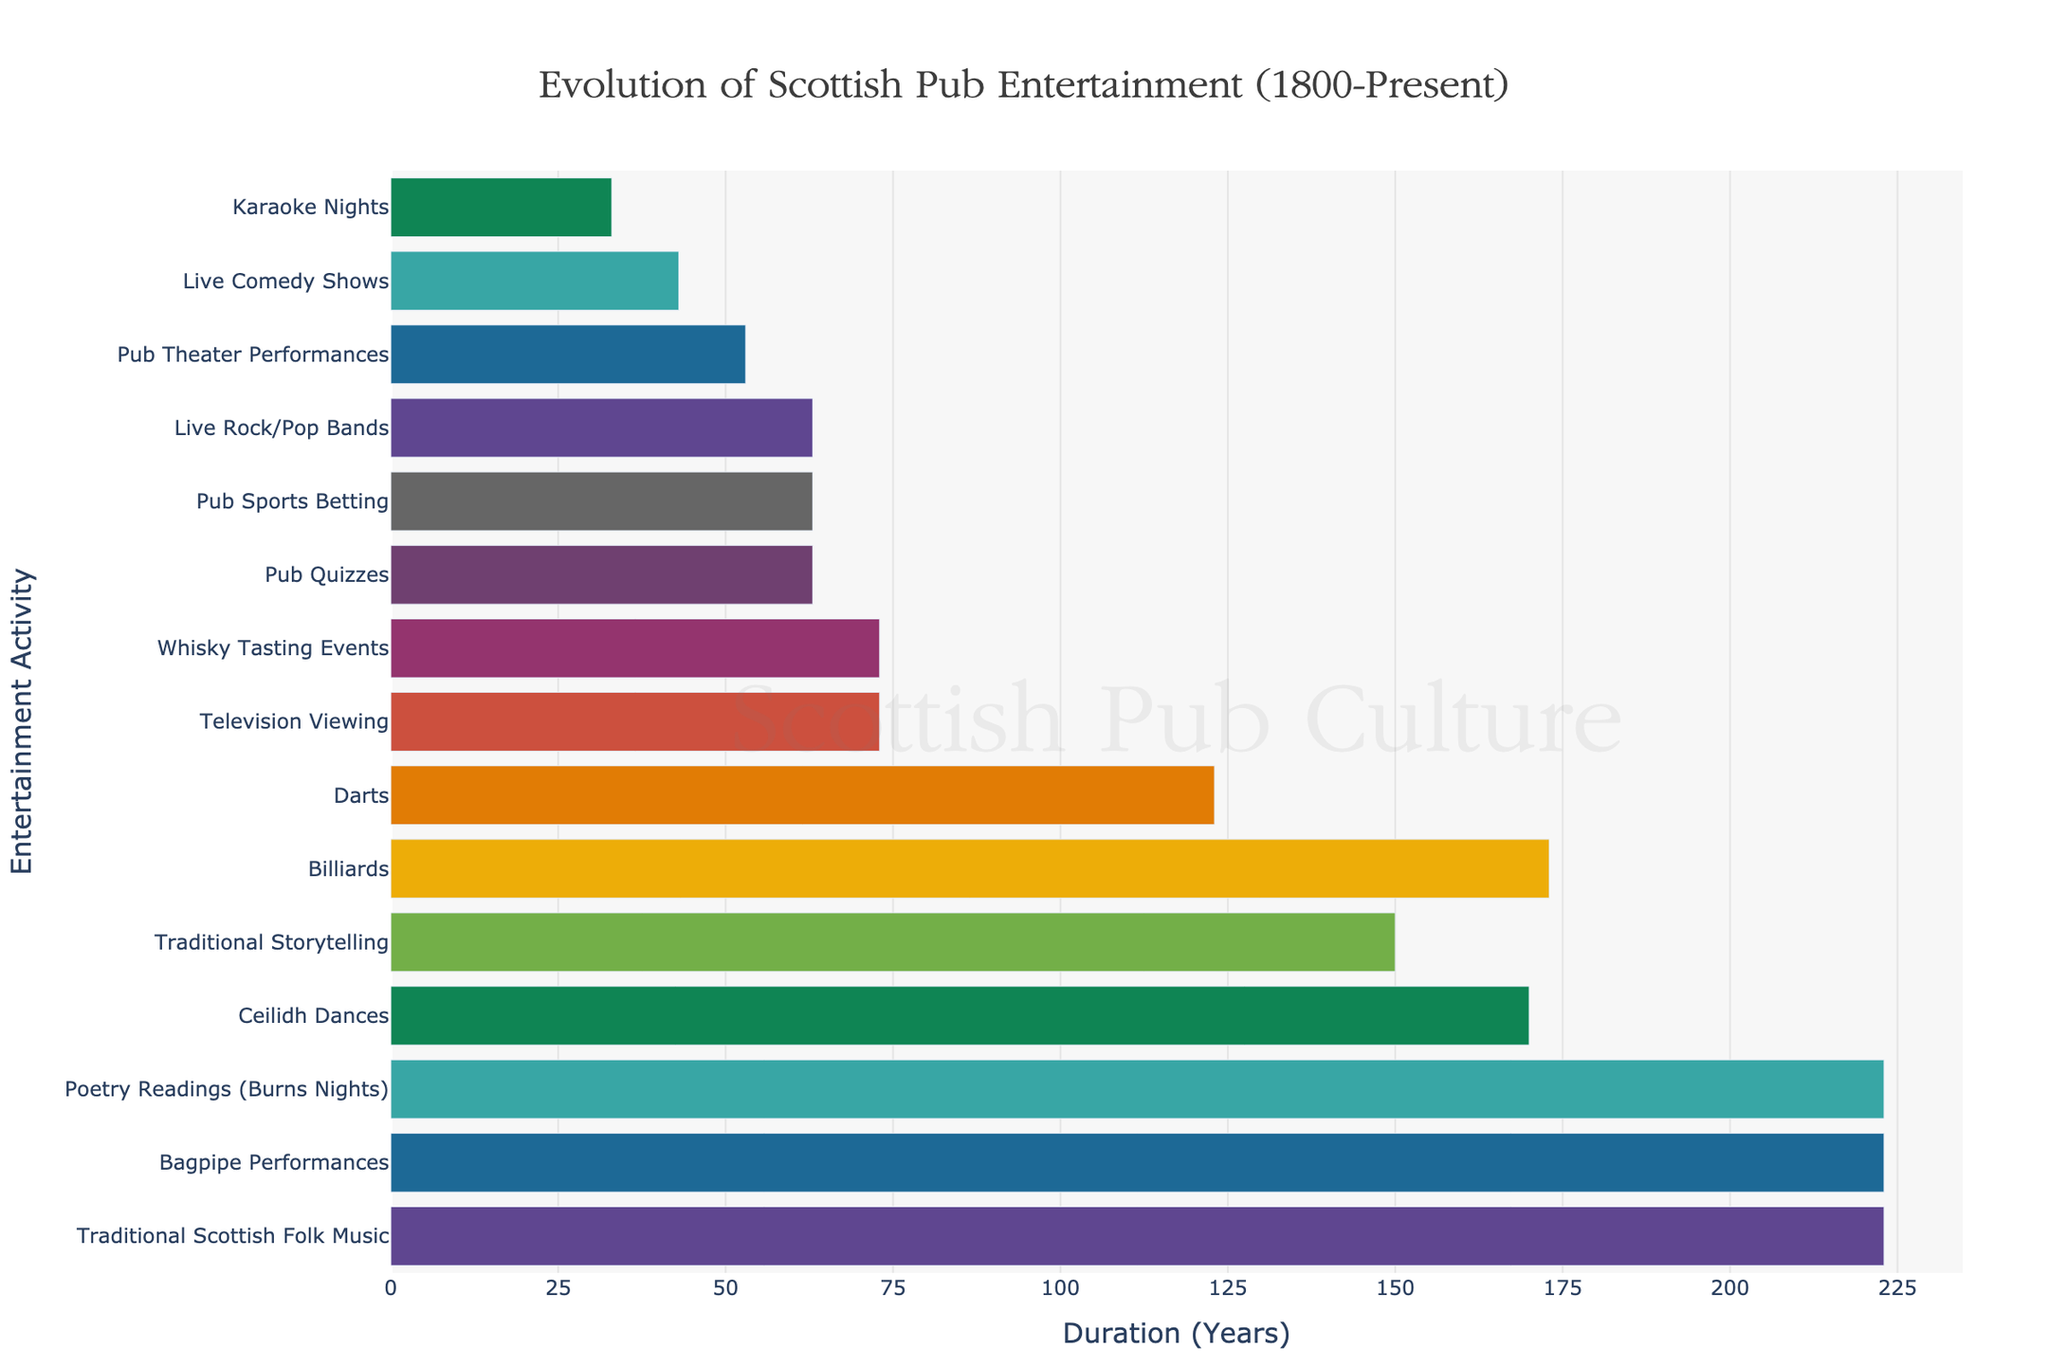What is the title of the Gantt Chart? The title is usually placed at the top of the chart. It's a straightforward observation.
Answer: Evolution of Scottish Pub Entertainment (1800-Present) Which activity on the chart has the shortest duration? Look at the horizontal length of the bars; the shortest bar corresponds to the shortest duration.
Answer: Traditional Storytelling Which activity started the earliest and is still ongoing today? Identify the activity that started in 1800 and extends to 2023.
Answer: Traditional Scottish Folk Music How many activities were introduced in the 20th century? Count the activities that started from 1900 to 1999.
Answer: 8 (Darts, Television Viewing, Pub Quizzes, Pub Sports Betting, Live Rock/Pop Bands, Live Comedy Shows, Pub Theater Performances, Karaoke Nights) Compare the duration of Traditional Storytelling and Ceilidh Dances. Which one lasted longer? Calculate the duration of each by considering their start and end years, then compare the two.
Answer: Ceilidh Dances Which activity related to music started in 1990? Locate the activity that began in 1990 and is related to music.
Answer: Karaoke Nights How many activities are still ongoing as of today? Count the activities that have an end year of 2023.
Answer: 12 During which period did Ceilidh Dances take place? Find the start and end years for Ceilidh Dances from the chart.
Answer: 1800-1970 Which activity related to a famous Scottish poet's readings has been ongoing since 1800? Identify the activity starting in 1800 specifically related to a famous poet (Robert Burns' readings).
Answer: Poetry Readings (Burns Nights) Which two activities that started in the 1960s are still ongoing today? Look for activities that began in the 1960s and have an end year of 2023.
Answer: Pub Quizzes, Live Rock/Pop Bands 